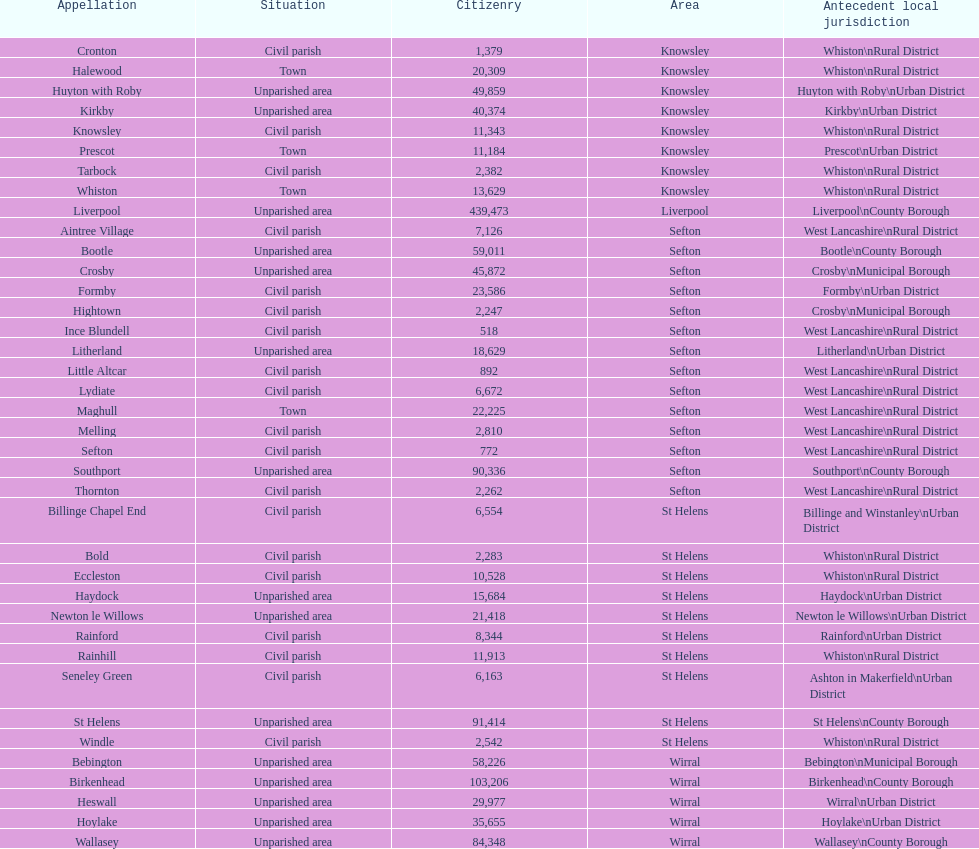Could you help me parse every detail presented in this table? {'header': ['Appellation', 'Situation', 'Citizenry', 'Area', 'Antecedent local jurisdiction'], 'rows': [['Cronton', 'Civil parish', '1,379', 'Knowsley', 'Whiston\\nRural District'], ['Halewood', 'Town', '20,309', 'Knowsley', 'Whiston\\nRural District'], ['Huyton with Roby', 'Unparished area', '49,859', 'Knowsley', 'Huyton with Roby\\nUrban District'], ['Kirkby', 'Unparished area', '40,374', 'Knowsley', 'Kirkby\\nUrban District'], ['Knowsley', 'Civil parish', '11,343', 'Knowsley', 'Whiston\\nRural District'], ['Prescot', 'Town', '11,184', 'Knowsley', 'Prescot\\nUrban District'], ['Tarbock', 'Civil parish', '2,382', 'Knowsley', 'Whiston\\nRural District'], ['Whiston', 'Town', '13,629', 'Knowsley', 'Whiston\\nRural District'], ['Liverpool', 'Unparished area', '439,473', 'Liverpool', 'Liverpool\\nCounty Borough'], ['Aintree Village', 'Civil parish', '7,126', 'Sefton', 'West Lancashire\\nRural District'], ['Bootle', 'Unparished area', '59,011', 'Sefton', 'Bootle\\nCounty Borough'], ['Crosby', 'Unparished area', '45,872', 'Sefton', 'Crosby\\nMunicipal Borough'], ['Formby', 'Civil parish', '23,586', 'Sefton', 'Formby\\nUrban District'], ['Hightown', 'Civil parish', '2,247', 'Sefton', 'Crosby\\nMunicipal Borough'], ['Ince Blundell', 'Civil parish', '518', 'Sefton', 'West Lancashire\\nRural District'], ['Litherland', 'Unparished area', '18,629', 'Sefton', 'Litherland\\nUrban District'], ['Little Altcar', 'Civil parish', '892', 'Sefton', 'West Lancashire\\nRural District'], ['Lydiate', 'Civil parish', '6,672', 'Sefton', 'West Lancashire\\nRural District'], ['Maghull', 'Town', '22,225', 'Sefton', 'West Lancashire\\nRural District'], ['Melling', 'Civil parish', '2,810', 'Sefton', 'West Lancashire\\nRural District'], ['Sefton', 'Civil parish', '772', 'Sefton', 'West Lancashire\\nRural District'], ['Southport', 'Unparished area', '90,336', 'Sefton', 'Southport\\nCounty Borough'], ['Thornton', 'Civil parish', '2,262', 'Sefton', 'West Lancashire\\nRural District'], ['Billinge Chapel End', 'Civil parish', '6,554', 'St Helens', 'Billinge and Winstanley\\nUrban District'], ['Bold', 'Civil parish', '2,283', 'St Helens', 'Whiston\\nRural District'], ['Eccleston', 'Civil parish', '10,528', 'St Helens', 'Whiston\\nRural District'], ['Haydock', 'Unparished area', '15,684', 'St Helens', 'Haydock\\nUrban District'], ['Newton le Willows', 'Unparished area', '21,418', 'St Helens', 'Newton le Willows\\nUrban District'], ['Rainford', 'Civil parish', '8,344', 'St Helens', 'Rainford\\nUrban District'], ['Rainhill', 'Civil parish', '11,913', 'St Helens', 'Whiston\\nRural District'], ['Seneley Green', 'Civil parish', '6,163', 'St Helens', 'Ashton in Makerfield\\nUrban District'], ['St Helens', 'Unparished area', '91,414', 'St Helens', 'St Helens\\nCounty Borough'], ['Windle', 'Civil parish', '2,542', 'St Helens', 'Whiston\\nRural District'], ['Bebington', 'Unparished area', '58,226', 'Wirral', 'Bebington\\nMunicipal Borough'], ['Birkenhead', 'Unparished area', '103,206', 'Wirral', 'Birkenhead\\nCounty Borough'], ['Heswall', 'Unparished area', '29,977', 'Wirral', 'Wirral\\nUrban District'], ['Hoylake', 'Unparished area', '35,655', 'Wirral', 'Hoylake\\nUrban District'], ['Wallasey', 'Unparished area', '84,348', 'Wirral', 'Wallasey\\nCounty Borough']]} Tell me the number of residents in formby. 23,586. 